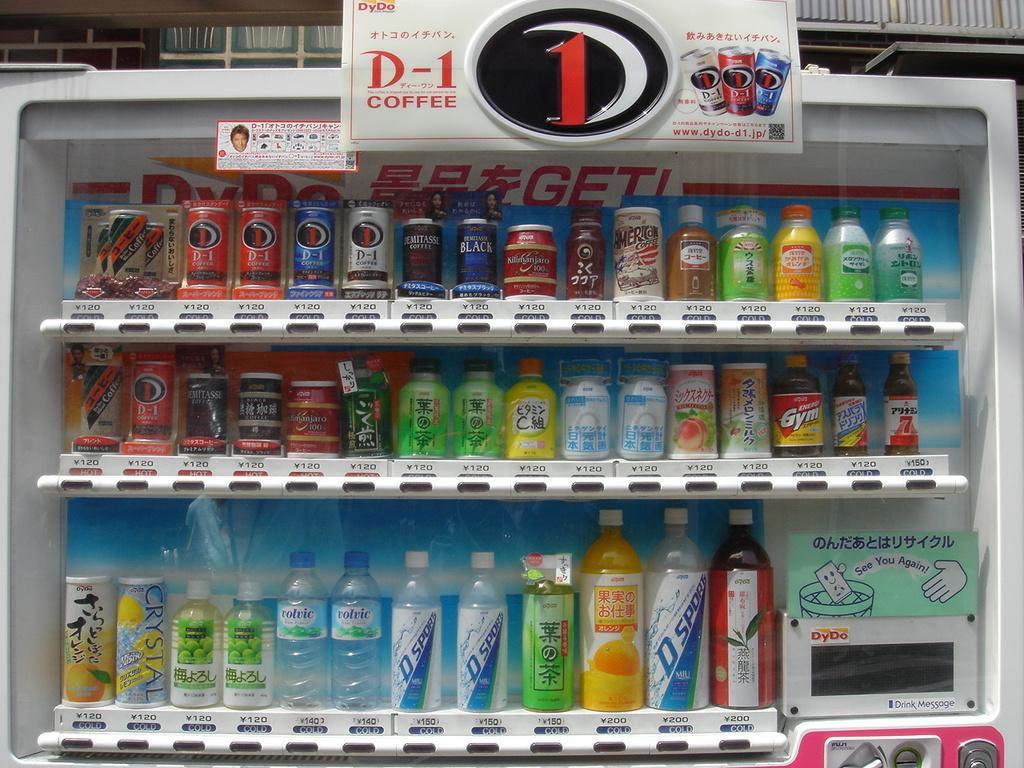<image>
Present a compact description of the photo's key features. Vending machine for drinks wiht a drink that says D Sport. 